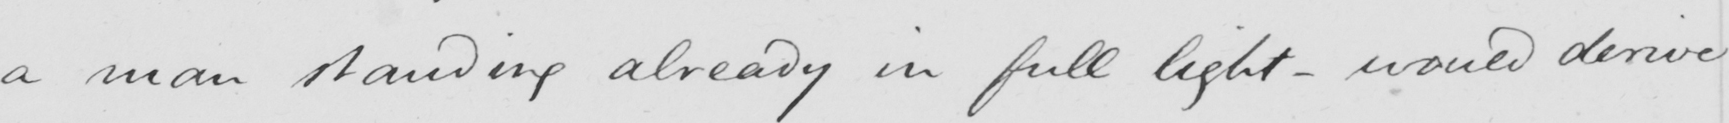Can you read and transcribe this handwriting? a man standing already in full light  _  would derive 